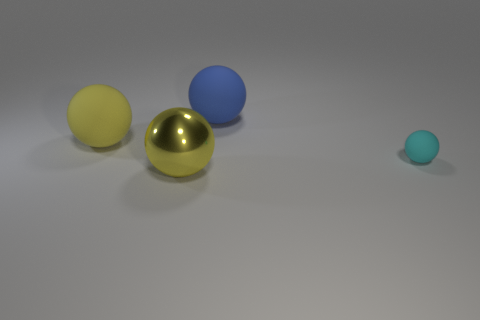Subtract all rubber spheres. How many spheres are left? 1 Add 1 small purple matte cubes. How many objects exist? 5 Subtract all yellow balls. How many balls are left? 2 Subtract 2 balls. How many balls are left? 2 Subtract all red blocks. How many brown balls are left? 0 Subtract all small cyan matte spheres. Subtract all large yellow matte things. How many objects are left? 2 Add 1 matte objects. How many matte objects are left? 4 Add 2 big blue matte things. How many big blue matte things exist? 3 Subtract 0 yellow cylinders. How many objects are left? 4 Subtract all red spheres. Subtract all brown cubes. How many spheres are left? 4 